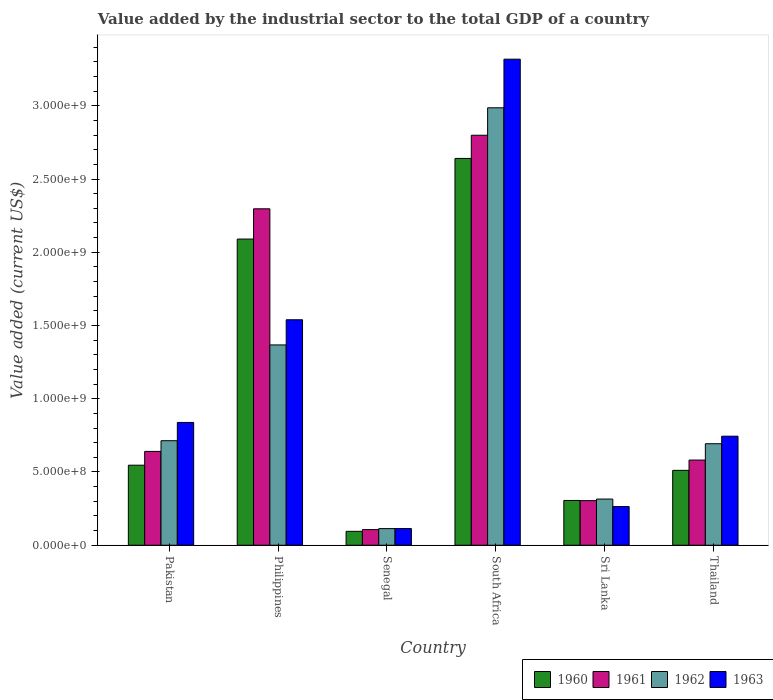Are the number of bars per tick equal to the number of legend labels?
Offer a terse response. Yes. How many bars are there on the 2nd tick from the left?
Provide a short and direct response. 4. How many bars are there on the 3rd tick from the right?
Your answer should be very brief. 4. What is the label of the 1st group of bars from the left?
Keep it short and to the point. Pakistan. What is the value added by the industrial sector to the total GDP in 1963 in Senegal?
Offer a very short reply. 1.14e+08. Across all countries, what is the maximum value added by the industrial sector to the total GDP in 1962?
Your answer should be compact. 2.99e+09. Across all countries, what is the minimum value added by the industrial sector to the total GDP in 1963?
Provide a short and direct response. 1.14e+08. In which country was the value added by the industrial sector to the total GDP in 1962 maximum?
Offer a very short reply. South Africa. In which country was the value added by the industrial sector to the total GDP in 1962 minimum?
Keep it short and to the point. Senegal. What is the total value added by the industrial sector to the total GDP in 1960 in the graph?
Give a very brief answer. 6.19e+09. What is the difference between the value added by the industrial sector to the total GDP in 1963 in Pakistan and that in Sri Lanka?
Make the answer very short. 5.74e+08. What is the difference between the value added by the industrial sector to the total GDP in 1962 in Sri Lanka and the value added by the industrial sector to the total GDP in 1963 in South Africa?
Offer a very short reply. -3.00e+09. What is the average value added by the industrial sector to the total GDP in 1961 per country?
Provide a short and direct response. 1.12e+09. What is the difference between the value added by the industrial sector to the total GDP of/in 1962 and value added by the industrial sector to the total GDP of/in 1963 in Thailand?
Your answer should be very brief. -5.15e+07. What is the ratio of the value added by the industrial sector to the total GDP in 1960 in Senegal to that in South Africa?
Your response must be concise. 0.04. Is the value added by the industrial sector to the total GDP in 1960 in Pakistan less than that in Philippines?
Make the answer very short. Yes. Is the difference between the value added by the industrial sector to the total GDP in 1962 in Philippines and Senegal greater than the difference between the value added by the industrial sector to the total GDP in 1963 in Philippines and Senegal?
Your response must be concise. No. What is the difference between the highest and the second highest value added by the industrial sector to the total GDP in 1962?
Provide a short and direct response. -6.54e+08. What is the difference between the highest and the lowest value added by the industrial sector to the total GDP in 1960?
Offer a very short reply. 2.55e+09. Is the sum of the value added by the industrial sector to the total GDP in 1960 in Philippines and Senegal greater than the maximum value added by the industrial sector to the total GDP in 1961 across all countries?
Provide a succinct answer. No. Is it the case that in every country, the sum of the value added by the industrial sector to the total GDP in 1962 and value added by the industrial sector to the total GDP in 1963 is greater than the sum of value added by the industrial sector to the total GDP in 1961 and value added by the industrial sector to the total GDP in 1960?
Your answer should be very brief. No. What does the 1st bar from the right in South Africa represents?
Keep it short and to the point. 1963. Are all the bars in the graph horizontal?
Your response must be concise. No. What is the difference between two consecutive major ticks on the Y-axis?
Your response must be concise. 5.00e+08. Are the values on the major ticks of Y-axis written in scientific E-notation?
Offer a terse response. Yes. Where does the legend appear in the graph?
Provide a short and direct response. Bottom right. How many legend labels are there?
Your answer should be compact. 4. What is the title of the graph?
Make the answer very short. Value added by the industrial sector to the total GDP of a country. Does "2008" appear as one of the legend labels in the graph?
Offer a very short reply. No. What is the label or title of the X-axis?
Offer a terse response. Country. What is the label or title of the Y-axis?
Give a very brief answer. Value added (current US$). What is the Value added (current US$) in 1960 in Pakistan?
Make the answer very short. 5.46e+08. What is the Value added (current US$) of 1961 in Pakistan?
Ensure brevity in your answer.  6.40e+08. What is the Value added (current US$) of 1962 in Pakistan?
Provide a succinct answer. 7.14e+08. What is the Value added (current US$) in 1963 in Pakistan?
Your answer should be compact. 8.38e+08. What is the Value added (current US$) in 1960 in Philippines?
Provide a short and direct response. 2.09e+09. What is the Value added (current US$) in 1961 in Philippines?
Give a very brief answer. 2.30e+09. What is the Value added (current US$) of 1962 in Philippines?
Ensure brevity in your answer.  1.37e+09. What is the Value added (current US$) of 1963 in Philippines?
Ensure brevity in your answer.  1.54e+09. What is the Value added (current US$) in 1960 in Senegal?
Give a very brief answer. 9.49e+07. What is the Value added (current US$) in 1961 in Senegal?
Your response must be concise. 1.07e+08. What is the Value added (current US$) of 1962 in Senegal?
Offer a terse response. 1.13e+08. What is the Value added (current US$) of 1963 in Senegal?
Your answer should be very brief. 1.14e+08. What is the Value added (current US$) in 1960 in South Africa?
Make the answer very short. 2.64e+09. What is the Value added (current US$) of 1961 in South Africa?
Give a very brief answer. 2.80e+09. What is the Value added (current US$) in 1962 in South Africa?
Offer a very short reply. 2.99e+09. What is the Value added (current US$) of 1963 in South Africa?
Your response must be concise. 3.32e+09. What is the Value added (current US$) in 1960 in Sri Lanka?
Offer a terse response. 3.06e+08. What is the Value added (current US$) in 1961 in Sri Lanka?
Give a very brief answer. 3.04e+08. What is the Value added (current US$) in 1962 in Sri Lanka?
Ensure brevity in your answer.  3.15e+08. What is the Value added (current US$) of 1963 in Sri Lanka?
Make the answer very short. 2.64e+08. What is the Value added (current US$) in 1960 in Thailand?
Make the answer very short. 5.11e+08. What is the Value added (current US$) in 1961 in Thailand?
Your response must be concise. 5.81e+08. What is the Value added (current US$) of 1962 in Thailand?
Your response must be concise. 6.93e+08. What is the Value added (current US$) of 1963 in Thailand?
Offer a terse response. 7.44e+08. Across all countries, what is the maximum Value added (current US$) in 1960?
Give a very brief answer. 2.64e+09. Across all countries, what is the maximum Value added (current US$) in 1961?
Ensure brevity in your answer.  2.80e+09. Across all countries, what is the maximum Value added (current US$) of 1962?
Your answer should be compact. 2.99e+09. Across all countries, what is the maximum Value added (current US$) in 1963?
Ensure brevity in your answer.  3.32e+09. Across all countries, what is the minimum Value added (current US$) in 1960?
Offer a terse response. 9.49e+07. Across all countries, what is the minimum Value added (current US$) in 1961?
Provide a short and direct response. 1.07e+08. Across all countries, what is the minimum Value added (current US$) in 1962?
Your answer should be very brief. 1.13e+08. Across all countries, what is the minimum Value added (current US$) in 1963?
Provide a short and direct response. 1.14e+08. What is the total Value added (current US$) in 1960 in the graph?
Ensure brevity in your answer.  6.19e+09. What is the total Value added (current US$) of 1961 in the graph?
Offer a very short reply. 6.73e+09. What is the total Value added (current US$) in 1962 in the graph?
Provide a succinct answer. 6.19e+09. What is the total Value added (current US$) in 1963 in the graph?
Your response must be concise. 6.82e+09. What is the difference between the Value added (current US$) in 1960 in Pakistan and that in Philippines?
Give a very brief answer. -1.54e+09. What is the difference between the Value added (current US$) of 1961 in Pakistan and that in Philippines?
Give a very brief answer. -1.66e+09. What is the difference between the Value added (current US$) in 1962 in Pakistan and that in Philippines?
Your response must be concise. -6.54e+08. What is the difference between the Value added (current US$) of 1963 in Pakistan and that in Philippines?
Offer a terse response. -7.01e+08. What is the difference between the Value added (current US$) in 1960 in Pakistan and that in Senegal?
Provide a succinct answer. 4.52e+08. What is the difference between the Value added (current US$) of 1961 in Pakistan and that in Senegal?
Offer a very short reply. 5.34e+08. What is the difference between the Value added (current US$) of 1962 in Pakistan and that in Senegal?
Ensure brevity in your answer.  6.00e+08. What is the difference between the Value added (current US$) in 1963 in Pakistan and that in Senegal?
Offer a very short reply. 7.24e+08. What is the difference between the Value added (current US$) of 1960 in Pakistan and that in South Africa?
Your response must be concise. -2.09e+09. What is the difference between the Value added (current US$) of 1961 in Pakistan and that in South Africa?
Your response must be concise. -2.16e+09. What is the difference between the Value added (current US$) of 1962 in Pakistan and that in South Africa?
Your response must be concise. -2.27e+09. What is the difference between the Value added (current US$) in 1963 in Pakistan and that in South Africa?
Offer a terse response. -2.48e+09. What is the difference between the Value added (current US$) in 1960 in Pakistan and that in Sri Lanka?
Ensure brevity in your answer.  2.41e+08. What is the difference between the Value added (current US$) in 1961 in Pakistan and that in Sri Lanka?
Keep it short and to the point. 3.36e+08. What is the difference between the Value added (current US$) of 1962 in Pakistan and that in Sri Lanka?
Offer a very short reply. 3.98e+08. What is the difference between the Value added (current US$) in 1963 in Pakistan and that in Sri Lanka?
Your answer should be very brief. 5.74e+08. What is the difference between the Value added (current US$) in 1960 in Pakistan and that in Thailand?
Your answer should be very brief. 3.52e+07. What is the difference between the Value added (current US$) of 1961 in Pakistan and that in Thailand?
Provide a succinct answer. 5.90e+07. What is the difference between the Value added (current US$) in 1962 in Pakistan and that in Thailand?
Offer a terse response. 2.06e+07. What is the difference between the Value added (current US$) in 1963 in Pakistan and that in Thailand?
Give a very brief answer. 9.39e+07. What is the difference between the Value added (current US$) in 1960 in Philippines and that in Senegal?
Provide a short and direct response. 2.00e+09. What is the difference between the Value added (current US$) of 1961 in Philippines and that in Senegal?
Ensure brevity in your answer.  2.19e+09. What is the difference between the Value added (current US$) of 1962 in Philippines and that in Senegal?
Provide a succinct answer. 1.25e+09. What is the difference between the Value added (current US$) in 1963 in Philippines and that in Senegal?
Your response must be concise. 1.43e+09. What is the difference between the Value added (current US$) of 1960 in Philippines and that in South Africa?
Your answer should be compact. -5.50e+08. What is the difference between the Value added (current US$) in 1961 in Philippines and that in South Africa?
Give a very brief answer. -5.02e+08. What is the difference between the Value added (current US$) of 1962 in Philippines and that in South Africa?
Your answer should be very brief. -1.62e+09. What is the difference between the Value added (current US$) of 1963 in Philippines and that in South Africa?
Offer a terse response. -1.78e+09. What is the difference between the Value added (current US$) of 1960 in Philippines and that in Sri Lanka?
Provide a succinct answer. 1.78e+09. What is the difference between the Value added (current US$) in 1961 in Philippines and that in Sri Lanka?
Provide a succinct answer. 1.99e+09. What is the difference between the Value added (current US$) in 1962 in Philippines and that in Sri Lanka?
Give a very brief answer. 1.05e+09. What is the difference between the Value added (current US$) in 1963 in Philippines and that in Sri Lanka?
Your response must be concise. 1.28e+09. What is the difference between the Value added (current US$) in 1960 in Philippines and that in Thailand?
Provide a succinct answer. 1.58e+09. What is the difference between the Value added (current US$) in 1961 in Philippines and that in Thailand?
Your answer should be compact. 1.72e+09. What is the difference between the Value added (current US$) in 1962 in Philippines and that in Thailand?
Keep it short and to the point. 6.74e+08. What is the difference between the Value added (current US$) of 1963 in Philippines and that in Thailand?
Offer a very short reply. 7.95e+08. What is the difference between the Value added (current US$) in 1960 in Senegal and that in South Africa?
Make the answer very short. -2.55e+09. What is the difference between the Value added (current US$) of 1961 in Senegal and that in South Africa?
Provide a succinct answer. -2.69e+09. What is the difference between the Value added (current US$) of 1962 in Senegal and that in South Africa?
Offer a very short reply. -2.87e+09. What is the difference between the Value added (current US$) of 1963 in Senegal and that in South Africa?
Provide a succinct answer. -3.20e+09. What is the difference between the Value added (current US$) of 1960 in Senegal and that in Sri Lanka?
Provide a short and direct response. -2.11e+08. What is the difference between the Value added (current US$) of 1961 in Senegal and that in Sri Lanka?
Ensure brevity in your answer.  -1.98e+08. What is the difference between the Value added (current US$) in 1962 in Senegal and that in Sri Lanka?
Make the answer very short. -2.02e+08. What is the difference between the Value added (current US$) of 1963 in Senegal and that in Sri Lanka?
Make the answer very short. -1.50e+08. What is the difference between the Value added (current US$) in 1960 in Senegal and that in Thailand?
Ensure brevity in your answer.  -4.16e+08. What is the difference between the Value added (current US$) of 1961 in Senegal and that in Thailand?
Your answer should be compact. -4.75e+08. What is the difference between the Value added (current US$) in 1962 in Senegal and that in Thailand?
Give a very brief answer. -5.79e+08. What is the difference between the Value added (current US$) of 1963 in Senegal and that in Thailand?
Your answer should be very brief. -6.31e+08. What is the difference between the Value added (current US$) of 1960 in South Africa and that in Sri Lanka?
Offer a terse response. 2.33e+09. What is the difference between the Value added (current US$) of 1961 in South Africa and that in Sri Lanka?
Offer a very short reply. 2.49e+09. What is the difference between the Value added (current US$) of 1962 in South Africa and that in Sri Lanka?
Keep it short and to the point. 2.67e+09. What is the difference between the Value added (current US$) of 1963 in South Africa and that in Sri Lanka?
Your response must be concise. 3.05e+09. What is the difference between the Value added (current US$) in 1960 in South Africa and that in Thailand?
Your answer should be very brief. 2.13e+09. What is the difference between the Value added (current US$) of 1961 in South Africa and that in Thailand?
Keep it short and to the point. 2.22e+09. What is the difference between the Value added (current US$) of 1962 in South Africa and that in Thailand?
Ensure brevity in your answer.  2.29e+09. What is the difference between the Value added (current US$) in 1963 in South Africa and that in Thailand?
Offer a terse response. 2.57e+09. What is the difference between the Value added (current US$) of 1960 in Sri Lanka and that in Thailand?
Your answer should be compact. -2.06e+08. What is the difference between the Value added (current US$) in 1961 in Sri Lanka and that in Thailand?
Make the answer very short. -2.77e+08. What is the difference between the Value added (current US$) of 1962 in Sri Lanka and that in Thailand?
Your answer should be compact. -3.78e+08. What is the difference between the Value added (current US$) of 1963 in Sri Lanka and that in Thailand?
Offer a very short reply. -4.80e+08. What is the difference between the Value added (current US$) in 1960 in Pakistan and the Value added (current US$) in 1961 in Philippines?
Your answer should be compact. -1.75e+09. What is the difference between the Value added (current US$) in 1960 in Pakistan and the Value added (current US$) in 1962 in Philippines?
Provide a succinct answer. -8.21e+08. What is the difference between the Value added (current US$) in 1960 in Pakistan and the Value added (current US$) in 1963 in Philippines?
Offer a terse response. -9.93e+08. What is the difference between the Value added (current US$) in 1961 in Pakistan and the Value added (current US$) in 1962 in Philippines?
Make the answer very short. -7.27e+08. What is the difference between the Value added (current US$) in 1961 in Pakistan and the Value added (current US$) in 1963 in Philippines?
Your response must be concise. -8.99e+08. What is the difference between the Value added (current US$) in 1962 in Pakistan and the Value added (current US$) in 1963 in Philippines?
Give a very brief answer. -8.26e+08. What is the difference between the Value added (current US$) in 1960 in Pakistan and the Value added (current US$) in 1961 in Senegal?
Keep it short and to the point. 4.40e+08. What is the difference between the Value added (current US$) of 1960 in Pakistan and the Value added (current US$) of 1962 in Senegal?
Make the answer very short. 4.33e+08. What is the difference between the Value added (current US$) of 1960 in Pakistan and the Value added (current US$) of 1963 in Senegal?
Provide a succinct answer. 4.32e+08. What is the difference between the Value added (current US$) of 1961 in Pakistan and the Value added (current US$) of 1962 in Senegal?
Your response must be concise. 5.27e+08. What is the difference between the Value added (current US$) of 1961 in Pakistan and the Value added (current US$) of 1963 in Senegal?
Give a very brief answer. 5.27e+08. What is the difference between the Value added (current US$) of 1962 in Pakistan and the Value added (current US$) of 1963 in Senegal?
Your answer should be compact. 6.00e+08. What is the difference between the Value added (current US$) in 1960 in Pakistan and the Value added (current US$) in 1961 in South Africa?
Make the answer very short. -2.25e+09. What is the difference between the Value added (current US$) of 1960 in Pakistan and the Value added (current US$) of 1962 in South Africa?
Offer a terse response. -2.44e+09. What is the difference between the Value added (current US$) in 1960 in Pakistan and the Value added (current US$) in 1963 in South Africa?
Your answer should be compact. -2.77e+09. What is the difference between the Value added (current US$) of 1961 in Pakistan and the Value added (current US$) of 1962 in South Africa?
Your answer should be very brief. -2.35e+09. What is the difference between the Value added (current US$) in 1961 in Pakistan and the Value added (current US$) in 1963 in South Africa?
Make the answer very short. -2.68e+09. What is the difference between the Value added (current US$) of 1962 in Pakistan and the Value added (current US$) of 1963 in South Africa?
Your response must be concise. -2.60e+09. What is the difference between the Value added (current US$) of 1960 in Pakistan and the Value added (current US$) of 1961 in Sri Lanka?
Provide a succinct answer. 2.42e+08. What is the difference between the Value added (current US$) of 1960 in Pakistan and the Value added (current US$) of 1962 in Sri Lanka?
Keep it short and to the point. 2.31e+08. What is the difference between the Value added (current US$) in 1960 in Pakistan and the Value added (current US$) in 1963 in Sri Lanka?
Your answer should be very brief. 2.82e+08. What is the difference between the Value added (current US$) in 1961 in Pakistan and the Value added (current US$) in 1962 in Sri Lanka?
Ensure brevity in your answer.  3.25e+08. What is the difference between the Value added (current US$) in 1961 in Pakistan and the Value added (current US$) in 1963 in Sri Lanka?
Give a very brief answer. 3.76e+08. What is the difference between the Value added (current US$) of 1962 in Pakistan and the Value added (current US$) of 1963 in Sri Lanka?
Give a very brief answer. 4.50e+08. What is the difference between the Value added (current US$) of 1960 in Pakistan and the Value added (current US$) of 1961 in Thailand?
Provide a succinct answer. -3.51e+07. What is the difference between the Value added (current US$) in 1960 in Pakistan and the Value added (current US$) in 1962 in Thailand?
Your answer should be compact. -1.47e+08. What is the difference between the Value added (current US$) in 1960 in Pakistan and the Value added (current US$) in 1963 in Thailand?
Your answer should be compact. -1.98e+08. What is the difference between the Value added (current US$) of 1961 in Pakistan and the Value added (current US$) of 1962 in Thailand?
Offer a terse response. -5.25e+07. What is the difference between the Value added (current US$) in 1961 in Pakistan and the Value added (current US$) in 1963 in Thailand?
Give a very brief answer. -1.04e+08. What is the difference between the Value added (current US$) of 1962 in Pakistan and the Value added (current US$) of 1963 in Thailand?
Your answer should be very brief. -3.09e+07. What is the difference between the Value added (current US$) in 1960 in Philippines and the Value added (current US$) in 1961 in Senegal?
Give a very brief answer. 1.98e+09. What is the difference between the Value added (current US$) in 1960 in Philippines and the Value added (current US$) in 1962 in Senegal?
Make the answer very short. 1.98e+09. What is the difference between the Value added (current US$) of 1960 in Philippines and the Value added (current US$) of 1963 in Senegal?
Your response must be concise. 1.98e+09. What is the difference between the Value added (current US$) in 1961 in Philippines and the Value added (current US$) in 1962 in Senegal?
Your response must be concise. 2.18e+09. What is the difference between the Value added (current US$) in 1961 in Philippines and the Value added (current US$) in 1963 in Senegal?
Make the answer very short. 2.18e+09. What is the difference between the Value added (current US$) of 1962 in Philippines and the Value added (current US$) of 1963 in Senegal?
Provide a short and direct response. 1.25e+09. What is the difference between the Value added (current US$) in 1960 in Philippines and the Value added (current US$) in 1961 in South Africa?
Keep it short and to the point. -7.09e+08. What is the difference between the Value added (current US$) in 1960 in Philippines and the Value added (current US$) in 1962 in South Africa?
Ensure brevity in your answer.  -8.96e+08. What is the difference between the Value added (current US$) in 1960 in Philippines and the Value added (current US$) in 1963 in South Africa?
Offer a terse response. -1.23e+09. What is the difference between the Value added (current US$) of 1961 in Philippines and the Value added (current US$) of 1962 in South Africa?
Offer a terse response. -6.90e+08. What is the difference between the Value added (current US$) in 1961 in Philippines and the Value added (current US$) in 1963 in South Africa?
Provide a succinct answer. -1.02e+09. What is the difference between the Value added (current US$) in 1962 in Philippines and the Value added (current US$) in 1963 in South Africa?
Offer a very short reply. -1.95e+09. What is the difference between the Value added (current US$) of 1960 in Philippines and the Value added (current US$) of 1961 in Sri Lanka?
Keep it short and to the point. 1.79e+09. What is the difference between the Value added (current US$) in 1960 in Philippines and the Value added (current US$) in 1962 in Sri Lanka?
Provide a succinct answer. 1.77e+09. What is the difference between the Value added (current US$) in 1960 in Philippines and the Value added (current US$) in 1963 in Sri Lanka?
Offer a very short reply. 1.83e+09. What is the difference between the Value added (current US$) in 1961 in Philippines and the Value added (current US$) in 1962 in Sri Lanka?
Your answer should be very brief. 1.98e+09. What is the difference between the Value added (current US$) in 1961 in Philippines and the Value added (current US$) in 1963 in Sri Lanka?
Offer a very short reply. 2.03e+09. What is the difference between the Value added (current US$) of 1962 in Philippines and the Value added (current US$) of 1963 in Sri Lanka?
Keep it short and to the point. 1.10e+09. What is the difference between the Value added (current US$) in 1960 in Philippines and the Value added (current US$) in 1961 in Thailand?
Your answer should be compact. 1.51e+09. What is the difference between the Value added (current US$) of 1960 in Philippines and the Value added (current US$) of 1962 in Thailand?
Your response must be concise. 1.40e+09. What is the difference between the Value added (current US$) of 1960 in Philippines and the Value added (current US$) of 1963 in Thailand?
Provide a succinct answer. 1.35e+09. What is the difference between the Value added (current US$) in 1961 in Philippines and the Value added (current US$) in 1962 in Thailand?
Keep it short and to the point. 1.60e+09. What is the difference between the Value added (current US$) of 1961 in Philippines and the Value added (current US$) of 1963 in Thailand?
Provide a short and direct response. 1.55e+09. What is the difference between the Value added (current US$) in 1962 in Philippines and the Value added (current US$) in 1963 in Thailand?
Offer a very short reply. 6.23e+08. What is the difference between the Value added (current US$) in 1960 in Senegal and the Value added (current US$) in 1961 in South Africa?
Provide a short and direct response. -2.70e+09. What is the difference between the Value added (current US$) in 1960 in Senegal and the Value added (current US$) in 1962 in South Africa?
Ensure brevity in your answer.  -2.89e+09. What is the difference between the Value added (current US$) in 1960 in Senegal and the Value added (current US$) in 1963 in South Africa?
Your response must be concise. -3.22e+09. What is the difference between the Value added (current US$) of 1961 in Senegal and the Value added (current US$) of 1962 in South Africa?
Give a very brief answer. -2.88e+09. What is the difference between the Value added (current US$) in 1961 in Senegal and the Value added (current US$) in 1963 in South Africa?
Your answer should be compact. -3.21e+09. What is the difference between the Value added (current US$) of 1962 in Senegal and the Value added (current US$) of 1963 in South Africa?
Make the answer very short. -3.20e+09. What is the difference between the Value added (current US$) in 1960 in Senegal and the Value added (current US$) in 1961 in Sri Lanka?
Offer a terse response. -2.10e+08. What is the difference between the Value added (current US$) of 1960 in Senegal and the Value added (current US$) of 1962 in Sri Lanka?
Ensure brevity in your answer.  -2.20e+08. What is the difference between the Value added (current US$) of 1960 in Senegal and the Value added (current US$) of 1963 in Sri Lanka?
Make the answer very short. -1.69e+08. What is the difference between the Value added (current US$) in 1961 in Senegal and the Value added (current US$) in 1962 in Sri Lanka?
Provide a short and direct response. -2.08e+08. What is the difference between the Value added (current US$) in 1961 in Senegal and the Value added (current US$) in 1963 in Sri Lanka?
Provide a short and direct response. -1.57e+08. What is the difference between the Value added (current US$) in 1962 in Senegal and the Value added (current US$) in 1963 in Sri Lanka?
Make the answer very short. -1.51e+08. What is the difference between the Value added (current US$) in 1960 in Senegal and the Value added (current US$) in 1961 in Thailand?
Ensure brevity in your answer.  -4.87e+08. What is the difference between the Value added (current US$) of 1960 in Senegal and the Value added (current US$) of 1962 in Thailand?
Your answer should be very brief. -5.98e+08. What is the difference between the Value added (current US$) in 1960 in Senegal and the Value added (current US$) in 1963 in Thailand?
Your answer should be compact. -6.50e+08. What is the difference between the Value added (current US$) in 1961 in Senegal and the Value added (current US$) in 1962 in Thailand?
Give a very brief answer. -5.86e+08. What is the difference between the Value added (current US$) in 1961 in Senegal and the Value added (current US$) in 1963 in Thailand?
Provide a short and direct response. -6.38e+08. What is the difference between the Value added (current US$) in 1962 in Senegal and the Value added (current US$) in 1963 in Thailand?
Provide a short and direct response. -6.31e+08. What is the difference between the Value added (current US$) in 1960 in South Africa and the Value added (current US$) in 1961 in Sri Lanka?
Provide a short and direct response. 2.34e+09. What is the difference between the Value added (current US$) of 1960 in South Africa and the Value added (current US$) of 1962 in Sri Lanka?
Your answer should be very brief. 2.33e+09. What is the difference between the Value added (current US$) in 1960 in South Africa and the Value added (current US$) in 1963 in Sri Lanka?
Offer a very short reply. 2.38e+09. What is the difference between the Value added (current US$) in 1961 in South Africa and the Value added (current US$) in 1962 in Sri Lanka?
Give a very brief answer. 2.48e+09. What is the difference between the Value added (current US$) of 1961 in South Africa and the Value added (current US$) of 1963 in Sri Lanka?
Keep it short and to the point. 2.53e+09. What is the difference between the Value added (current US$) of 1962 in South Africa and the Value added (current US$) of 1963 in Sri Lanka?
Offer a terse response. 2.72e+09. What is the difference between the Value added (current US$) in 1960 in South Africa and the Value added (current US$) in 1961 in Thailand?
Your answer should be very brief. 2.06e+09. What is the difference between the Value added (current US$) of 1960 in South Africa and the Value added (current US$) of 1962 in Thailand?
Offer a terse response. 1.95e+09. What is the difference between the Value added (current US$) of 1960 in South Africa and the Value added (current US$) of 1963 in Thailand?
Your answer should be very brief. 1.90e+09. What is the difference between the Value added (current US$) of 1961 in South Africa and the Value added (current US$) of 1962 in Thailand?
Your response must be concise. 2.11e+09. What is the difference between the Value added (current US$) of 1961 in South Africa and the Value added (current US$) of 1963 in Thailand?
Your answer should be very brief. 2.05e+09. What is the difference between the Value added (current US$) in 1962 in South Africa and the Value added (current US$) in 1963 in Thailand?
Ensure brevity in your answer.  2.24e+09. What is the difference between the Value added (current US$) in 1960 in Sri Lanka and the Value added (current US$) in 1961 in Thailand?
Provide a short and direct response. -2.76e+08. What is the difference between the Value added (current US$) in 1960 in Sri Lanka and the Value added (current US$) in 1962 in Thailand?
Offer a terse response. -3.87e+08. What is the difference between the Value added (current US$) in 1960 in Sri Lanka and the Value added (current US$) in 1963 in Thailand?
Provide a succinct answer. -4.39e+08. What is the difference between the Value added (current US$) in 1961 in Sri Lanka and the Value added (current US$) in 1962 in Thailand?
Make the answer very short. -3.89e+08. What is the difference between the Value added (current US$) in 1961 in Sri Lanka and the Value added (current US$) in 1963 in Thailand?
Offer a terse response. -4.40e+08. What is the difference between the Value added (current US$) of 1962 in Sri Lanka and the Value added (current US$) of 1963 in Thailand?
Make the answer very short. -4.29e+08. What is the average Value added (current US$) of 1960 per country?
Offer a terse response. 1.03e+09. What is the average Value added (current US$) of 1961 per country?
Offer a very short reply. 1.12e+09. What is the average Value added (current US$) of 1962 per country?
Your answer should be compact. 1.03e+09. What is the average Value added (current US$) of 1963 per country?
Keep it short and to the point. 1.14e+09. What is the difference between the Value added (current US$) of 1960 and Value added (current US$) of 1961 in Pakistan?
Offer a very short reply. -9.41e+07. What is the difference between the Value added (current US$) of 1960 and Value added (current US$) of 1962 in Pakistan?
Make the answer very short. -1.67e+08. What is the difference between the Value added (current US$) in 1960 and Value added (current US$) in 1963 in Pakistan?
Make the answer very short. -2.92e+08. What is the difference between the Value added (current US$) in 1961 and Value added (current US$) in 1962 in Pakistan?
Make the answer very short. -7.31e+07. What is the difference between the Value added (current US$) of 1961 and Value added (current US$) of 1963 in Pakistan?
Make the answer very short. -1.98e+08. What is the difference between the Value added (current US$) of 1962 and Value added (current US$) of 1963 in Pakistan?
Your answer should be very brief. -1.25e+08. What is the difference between the Value added (current US$) of 1960 and Value added (current US$) of 1961 in Philippines?
Your answer should be compact. -2.07e+08. What is the difference between the Value added (current US$) of 1960 and Value added (current US$) of 1962 in Philippines?
Your response must be concise. 7.23e+08. What is the difference between the Value added (current US$) in 1960 and Value added (current US$) in 1963 in Philippines?
Ensure brevity in your answer.  5.51e+08. What is the difference between the Value added (current US$) of 1961 and Value added (current US$) of 1962 in Philippines?
Give a very brief answer. 9.29e+08. What is the difference between the Value added (current US$) of 1961 and Value added (current US$) of 1963 in Philippines?
Offer a terse response. 7.57e+08. What is the difference between the Value added (current US$) of 1962 and Value added (current US$) of 1963 in Philippines?
Make the answer very short. -1.72e+08. What is the difference between the Value added (current US$) of 1960 and Value added (current US$) of 1961 in Senegal?
Make the answer very short. -1.19e+07. What is the difference between the Value added (current US$) in 1960 and Value added (current US$) in 1962 in Senegal?
Offer a terse response. -1.86e+07. What is the difference between the Value added (current US$) of 1960 and Value added (current US$) of 1963 in Senegal?
Make the answer very short. -1.91e+07. What is the difference between the Value added (current US$) of 1961 and Value added (current US$) of 1962 in Senegal?
Your answer should be very brief. -6.73e+06. What is the difference between the Value added (current US$) of 1961 and Value added (current US$) of 1963 in Senegal?
Provide a short and direct response. -7.17e+06. What is the difference between the Value added (current US$) in 1962 and Value added (current US$) in 1963 in Senegal?
Your answer should be compact. -4.40e+05. What is the difference between the Value added (current US$) in 1960 and Value added (current US$) in 1961 in South Africa?
Make the answer very short. -1.58e+08. What is the difference between the Value added (current US$) of 1960 and Value added (current US$) of 1962 in South Africa?
Provide a succinct answer. -3.46e+08. What is the difference between the Value added (current US$) in 1960 and Value added (current US$) in 1963 in South Africa?
Provide a succinct answer. -6.78e+08. What is the difference between the Value added (current US$) of 1961 and Value added (current US$) of 1962 in South Africa?
Ensure brevity in your answer.  -1.87e+08. What is the difference between the Value added (current US$) in 1961 and Value added (current US$) in 1963 in South Africa?
Offer a terse response. -5.19e+08. What is the difference between the Value added (current US$) in 1962 and Value added (current US$) in 1963 in South Africa?
Your answer should be compact. -3.32e+08. What is the difference between the Value added (current US$) in 1960 and Value added (current US$) in 1961 in Sri Lanka?
Your response must be concise. 1.26e+06. What is the difference between the Value added (current US$) of 1960 and Value added (current US$) of 1962 in Sri Lanka?
Offer a very short reply. -9.55e+06. What is the difference between the Value added (current US$) in 1960 and Value added (current US$) in 1963 in Sri Lanka?
Your response must be concise. 4.16e+07. What is the difference between the Value added (current US$) of 1961 and Value added (current US$) of 1962 in Sri Lanka?
Your response must be concise. -1.08e+07. What is the difference between the Value added (current US$) of 1961 and Value added (current US$) of 1963 in Sri Lanka?
Ensure brevity in your answer.  4.04e+07. What is the difference between the Value added (current US$) in 1962 and Value added (current US$) in 1963 in Sri Lanka?
Offer a very short reply. 5.12e+07. What is the difference between the Value added (current US$) in 1960 and Value added (current US$) in 1961 in Thailand?
Give a very brief answer. -7.03e+07. What is the difference between the Value added (current US$) in 1960 and Value added (current US$) in 1962 in Thailand?
Offer a terse response. -1.82e+08. What is the difference between the Value added (current US$) in 1960 and Value added (current US$) in 1963 in Thailand?
Ensure brevity in your answer.  -2.33e+08. What is the difference between the Value added (current US$) in 1961 and Value added (current US$) in 1962 in Thailand?
Make the answer very short. -1.12e+08. What is the difference between the Value added (current US$) of 1961 and Value added (current US$) of 1963 in Thailand?
Your response must be concise. -1.63e+08. What is the difference between the Value added (current US$) in 1962 and Value added (current US$) in 1963 in Thailand?
Your response must be concise. -5.15e+07. What is the ratio of the Value added (current US$) in 1960 in Pakistan to that in Philippines?
Your response must be concise. 0.26. What is the ratio of the Value added (current US$) of 1961 in Pakistan to that in Philippines?
Provide a succinct answer. 0.28. What is the ratio of the Value added (current US$) in 1962 in Pakistan to that in Philippines?
Your answer should be very brief. 0.52. What is the ratio of the Value added (current US$) in 1963 in Pakistan to that in Philippines?
Keep it short and to the point. 0.54. What is the ratio of the Value added (current US$) in 1960 in Pakistan to that in Senegal?
Make the answer very short. 5.76. What is the ratio of the Value added (current US$) in 1961 in Pakistan to that in Senegal?
Ensure brevity in your answer.  6. What is the ratio of the Value added (current US$) in 1962 in Pakistan to that in Senegal?
Offer a very short reply. 6.29. What is the ratio of the Value added (current US$) in 1963 in Pakistan to that in Senegal?
Make the answer very short. 7.36. What is the ratio of the Value added (current US$) of 1960 in Pakistan to that in South Africa?
Ensure brevity in your answer.  0.21. What is the ratio of the Value added (current US$) of 1961 in Pakistan to that in South Africa?
Give a very brief answer. 0.23. What is the ratio of the Value added (current US$) in 1962 in Pakistan to that in South Africa?
Give a very brief answer. 0.24. What is the ratio of the Value added (current US$) in 1963 in Pakistan to that in South Africa?
Your answer should be very brief. 0.25. What is the ratio of the Value added (current US$) in 1960 in Pakistan to that in Sri Lanka?
Offer a terse response. 1.79. What is the ratio of the Value added (current US$) in 1961 in Pakistan to that in Sri Lanka?
Your response must be concise. 2.1. What is the ratio of the Value added (current US$) in 1962 in Pakistan to that in Sri Lanka?
Ensure brevity in your answer.  2.26. What is the ratio of the Value added (current US$) in 1963 in Pakistan to that in Sri Lanka?
Provide a short and direct response. 3.17. What is the ratio of the Value added (current US$) of 1960 in Pakistan to that in Thailand?
Your answer should be very brief. 1.07. What is the ratio of the Value added (current US$) in 1961 in Pakistan to that in Thailand?
Your answer should be very brief. 1.1. What is the ratio of the Value added (current US$) of 1962 in Pakistan to that in Thailand?
Provide a short and direct response. 1.03. What is the ratio of the Value added (current US$) of 1963 in Pakistan to that in Thailand?
Provide a succinct answer. 1.13. What is the ratio of the Value added (current US$) in 1960 in Philippines to that in Senegal?
Give a very brief answer. 22.03. What is the ratio of the Value added (current US$) of 1961 in Philippines to that in Senegal?
Your answer should be very brief. 21.51. What is the ratio of the Value added (current US$) of 1962 in Philippines to that in Senegal?
Ensure brevity in your answer.  12.05. What is the ratio of the Value added (current US$) of 1963 in Philippines to that in Senegal?
Provide a succinct answer. 13.51. What is the ratio of the Value added (current US$) of 1960 in Philippines to that in South Africa?
Provide a succinct answer. 0.79. What is the ratio of the Value added (current US$) in 1961 in Philippines to that in South Africa?
Make the answer very short. 0.82. What is the ratio of the Value added (current US$) in 1962 in Philippines to that in South Africa?
Your answer should be compact. 0.46. What is the ratio of the Value added (current US$) in 1963 in Philippines to that in South Africa?
Offer a very short reply. 0.46. What is the ratio of the Value added (current US$) in 1960 in Philippines to that in Sri Lanka?
Make the answer very short. 6.84. What is the ratio of the Value added (current US$) in 1961 in Philippines to that in Sri Lanka?
Your answer should be very brief. 7.54. What is the ratio of the Value added (current US$) of 1962 in Philippines to that in Sri Lanka?
Give a very brief answer. 4.34. What is the ratio of the Value added (current US$) of 1963 in Philippines to that in Sri Lanka?
Make the answer very short. 5.83. What is the ratio of the Value added (current US$) of 1960 in Philippines to that in Thailand?
Provide a short and direct response. 4.09. What is the ratio of the Value added (current US$) in 1961 in Philippines to that in Thailand?
Keep it short and to the point. 3.95. What is the ratio of the Value added (current US$) in 1962 in Philippines to that in Thailand?
Your response must be concise. 1.97. What is the ratio of the Value added (current US$) of 1963 in Philippines to that in Thailand?
Make the answer very short. 2.07. What is the ratio of the Value added (current US$) of 1960 in Senegal to that in South Africa?
Offer a very short reply. 0.04. What is the ratio of the Value added (current US$) in 1961 in Senegal to that in South Africa?
Give a very brief answer. 0.04. What is the ratio of the Value added (current US$) of 1962 in Senegal to that in South Africa?
Your response must be concise. 0.04. What is the ratio of the Value added (current US$) in 1963 in Senegal to that in South Africa?
Make the answer very short. 0.03. What is the ratio of the Value added (current US$) of 1960 in Senegal to that in Sri Lanka?
Offer a very short reply. 0.31. What is the ratio of the Value added (current US$) in 1961 in Senegal to that in Sri Lanka?
Ensure brevity in your answer.  0.35. What is the ratio of the Value added (current US$) in 1962 in Senegal to that in Sri Lanka?
Make the answer very short. 0.36. What is the ratio of the Value added (current US$) of 1963 in Senegal to that in Sri Lanka?
Make the answer very short. 0.43. What is the ratio of the Value added (current US$) of 1960 in Senegal to that in Thailand?
Make the answer very short. 0.19. What is the ratio of the Value added (current US$) of 1961 in Senegal to that in Thailand?
Provide a succinct answer. 0.18. What is the ratio of the Value added (current US$) in 1962 in Senegal to that in Thailand?
Provide a short and direct response. 0.16. What is the ratio of the Value added (current US$) in 1963 in Senegal to that in Thailand?
Your answer should be very brief. 0.15. What is the ratio of the Value added (current US$) of 1960 in South Africa to that in Sri Lanka?
Provide a short and direct response. 8.64. What is the ratio of the Value added (current US$) of 1961 in South Africa to that in Sri Lanka?
Give a very brief answer. 9.19. What is the ratio of the Value added (current US$) in 1962 in South Africa to that in Sri Lanka?
Your response must be concise. 9.47. What is the ratio of the Value added (current US$) in 1963 in South Africa to that in Sri Lanka?
Keep it short and to the point. 12.57. What is the ratio of the Value added (current US$) in 1960 in South Africa to that in Thailand?
Provide a succinct answer. 5.17. What is the ratio of the Value added (current US$) in 1961 in South Africa to that in Thailand?
Offer a terse response. 4.81. What is the ratio of the Value added (current US$) in 1962 in South Africa to that in Thailand?
Offer a terse response. 4.31. What is the ratio of the Value added (current US$) in 1963 in South Africa to that in Thailand?
Your answer should be very brief. 4.46. What is the ratio of the Value added (current US$) of 1960 in Sri Lanka to that in Thailand?
Make the answer very short. 0.6. What is the ratio of the Value added (current US$) of 1961 in Sri Lanka to that in Thailand?
Provide a succinct answer. 0.52. What is the ratio of the Value added (current US$) of 1962 in Sri Lanka to that in Thailand?
Provide a succinct answer. 0.45. What is the ratio of the Value added (current US$) in 1963 in Sri Lanka to that in Thailand?
Your response must be concise. 0.35. What is the difference between the highest and the second highest Value added (current US$) of 1960?
Make the answer very short. 5.50e+08. What is the difference between the highest and the second highest Value added (current US$) in 1961?
Your answer should be very brief. 5.02e+08. What is the difference between the highest and the second highest Value added (current US$) in 1962?
Your answer should be compact. 1.62e+09. What is the difference between the highest and the second highest Value added (current US$) in 1963?
Keep it short and to the point. 1.78e+09. What is the difference between the highest and the lowest Value added (current US$) in 1960?
Your answer should be very brief. 2.55e+09. What is the difference between the highest and the lowest Value added (current US$) of 1961?
Your answer should be compact. 2.69e+09. What is the difference between the highest and the lowest Value added (current US$) in 1962?
Offer a very short reply. 2.87e+09. What is the difference between the highest and the lowest Value added (current US$) in 1963?
Your response must be concise. 3.20e+09. 